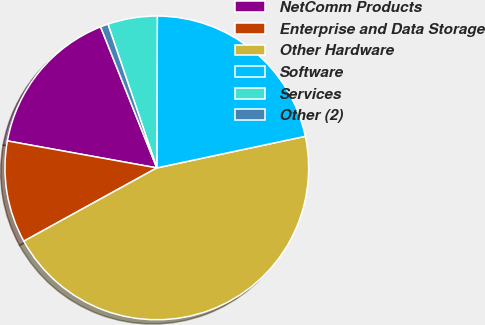<chart> <loc_0><loc_0><loc_500><loc_500><pie_chart><fcel>NetComm Products<fcel>Enterprise and Data Storage<fcel>Other Hardware<fcel>Software<fcel>Services<fcel>Other (2)<nl><fcel>16.12%<fcel>10.86%<fcel>45.32%<fcel>21.61%<fcel>5.27%<fcel>0.82%<nl></chart> 